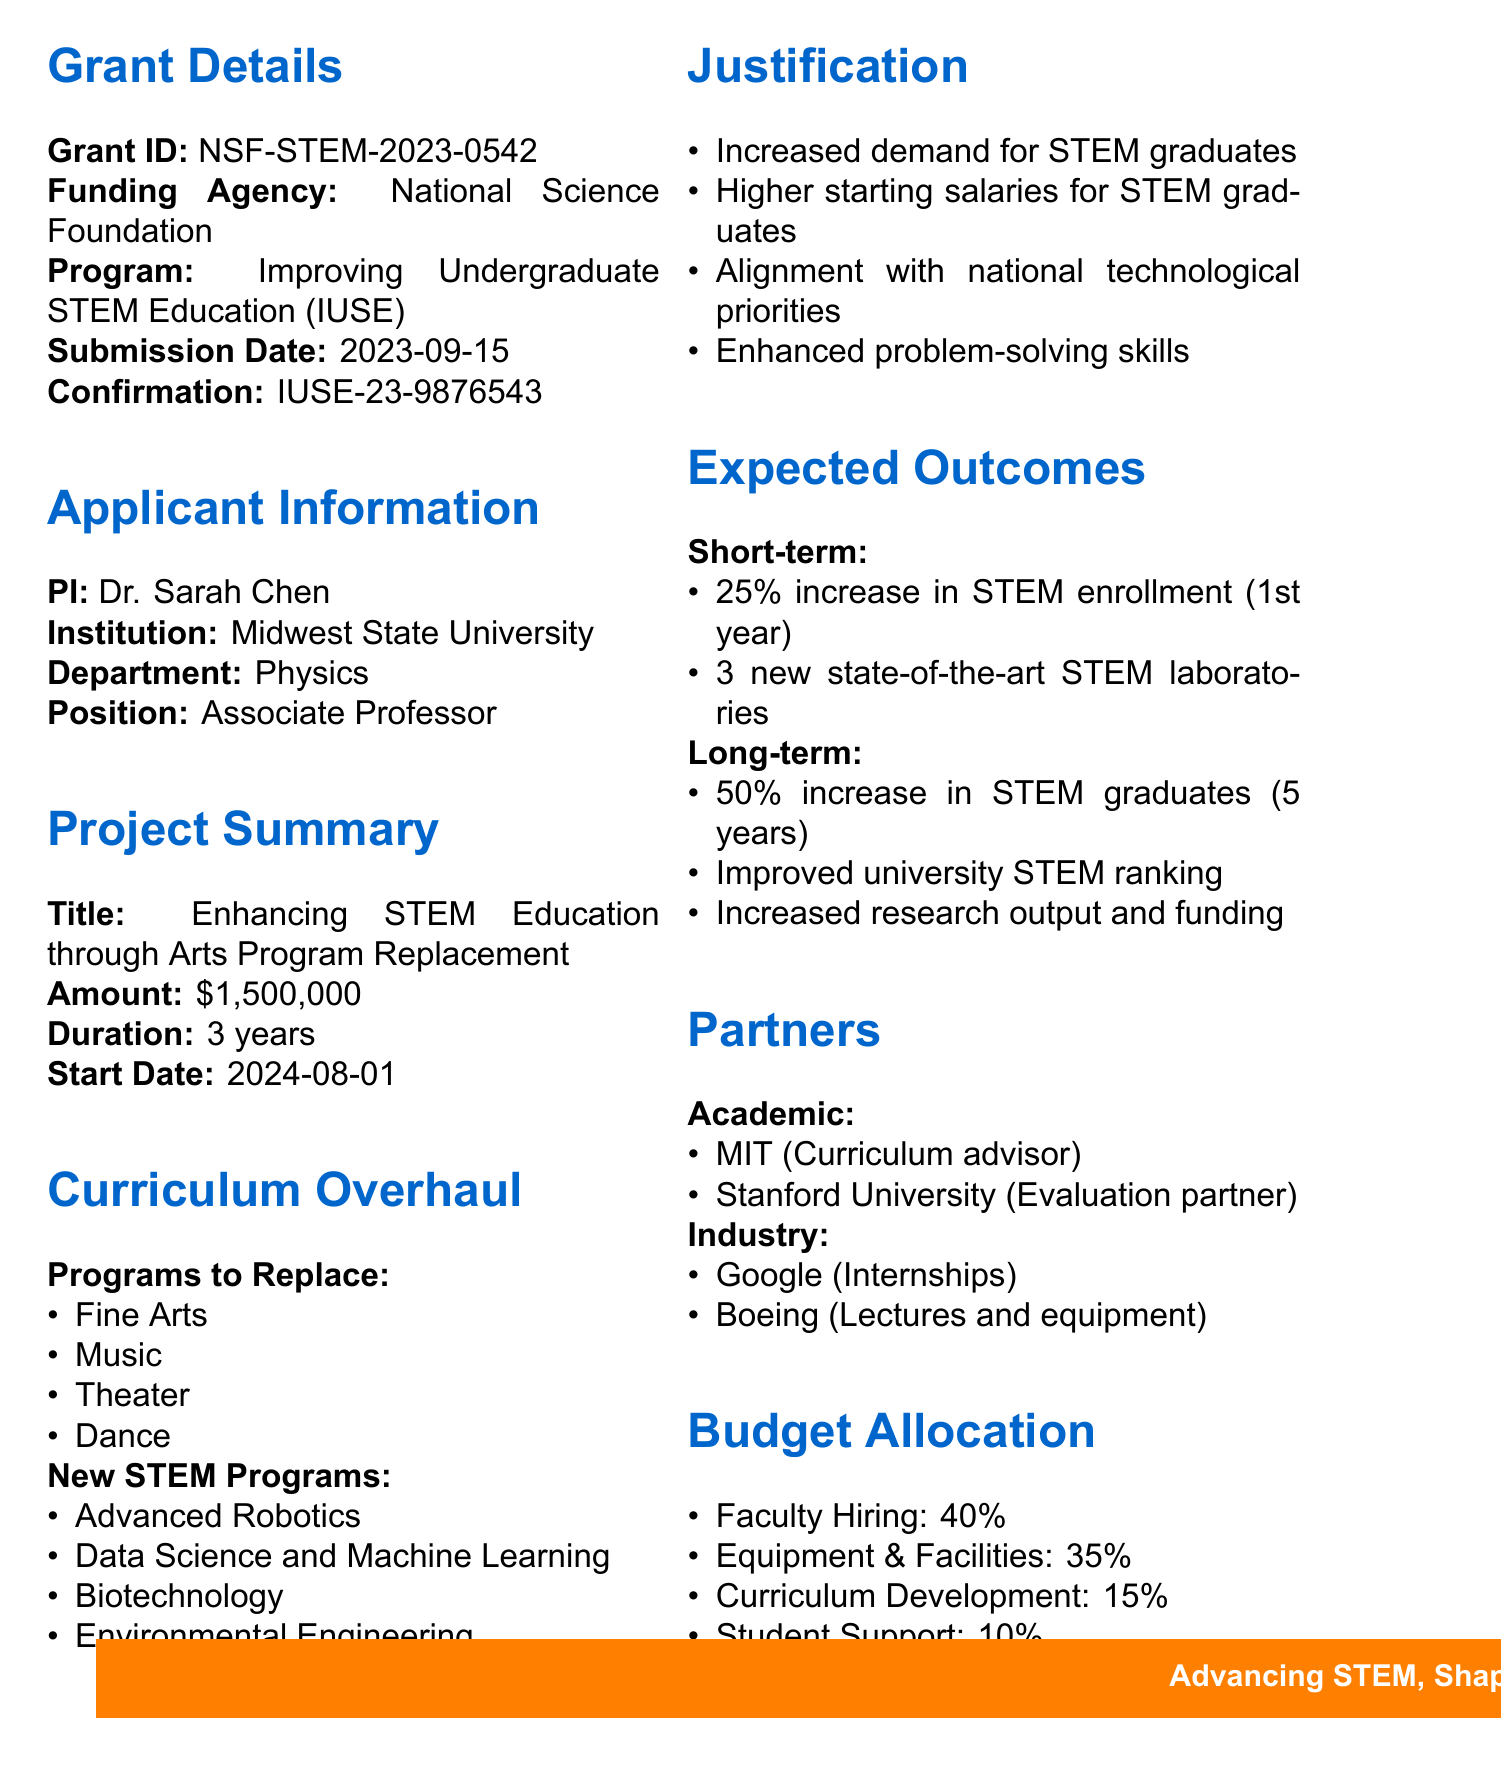what is the grant ID? The grant ID can be found in the grant details section of the document, which states "NSF-STEM-2023-0542."
Answer: NSF-STEM-2023-0542 who is the principal investigator? The principal investigator is mentioned in the applicant information section as Dr. Sarah Chen.
Answer: Dr. Sarah Chen what is the requested amount for the project? The requested amount is specified in the project summary section, listed as "$1,500,000."
Answer: $1,500,000 how many new STEM laboratories are expected to be established? This information is found in the expected outcomes section, which states "3 new state-of-the-art STEM laboratories."
Answer: 3 which institution is collaborating as a curriculum development advisor? The collaborating institution acting as a curriculum development advisor is stated in the partners section as "Massachusetts Institute of Technology."
Answer: Massachusetts Institute of Technology what percentage of the budget is allocated for faculty hiring? The budget allocation section specifies the allocation, indicating that "40%" is for faculty hiring.
Answer: 40% what is the estimated review time for the grant application? The review process section provides the estimated review time, which is "4-6 months."
Answer: 4-6 months which new program focuses on computational fields? The new program that focuses on computational fields is listed under proposed replacements as "Data Science and Machine Learning."
Answer: Data Science and Machine Learning what are the expected long-term outcomes for STEM graduates in percentage? The long-term outcome for STEM graduates is indicated to be "50% increase in STEM graduates over 5 years."
Answer: 50% 